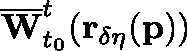<formula> <loc_0><loc_0><loc_500><loc_500>\overline { W } _ { t _ { 0 } } ^ { t } ( r _ { \delta \eta } ( p ) )</formula> 